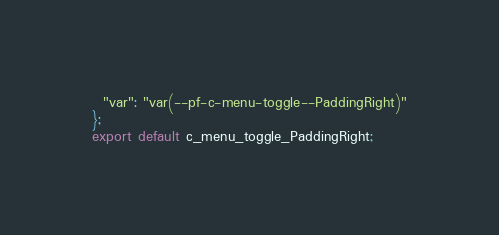<code> <loc_0><loc_0><loc_500><loc_500><_JavaScript_>  "var": "var(--pf-c-menu-toggle--PaddingRight)"
};
export default c_menu_toggle_PaddingRight;</code> 